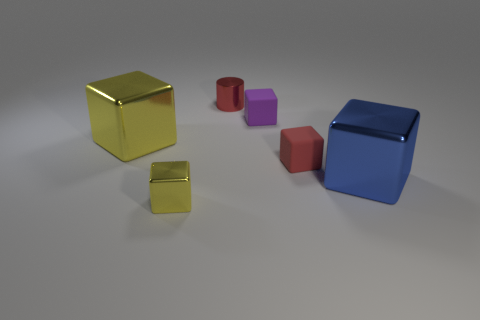Subtract 1 blocks. How many blocks are left? 4 Subtract all blue cubes. How many cubes are left? 4 Subtract all green cubes. Subtract all cyan cylinders. How many cubes are left? 5 Add 2 small metal cylinders. How many objects exist? 8 Subtract all cylinders. How many objects are left? 5 Add 6 big blue cubes. How many big blue cubes exist? 7 Subtract 0 gray cylinders. How many objects are left? 6 Subtract all yellow shiny objects. Subtract all big blocks. How many objects are left? 2 Add 2 purple cubes. How many purple cubes are left? 3 